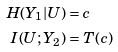Convert formula to latex. <formula><loc_0><loc_0><loc_500><loc_500>H ( Y _ { 1 } | U ) & = c \\ I ( U ; Y _ { 2 } ) & = T ( c )</formula> 